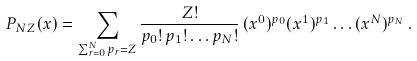<formula> <loc_0><loc_0><loc_500><loc_500>P _ { N Z } ( x ) = \sum _ { \sum _ { r = 0 } ^ { N } p _ { r } = Z } \frac { Z ! } { p _ { 0 } ! \, p _ { 1 } ! \dots p _ { N } ! } \, ( x ^ { 0 } ) ^ { p _ { 0 } } ( x ^ { 1 } ) ^ { p _ { 1 } } \dots ( x ^ { N } ) ^ { p _ { N } } \, .</formula> 